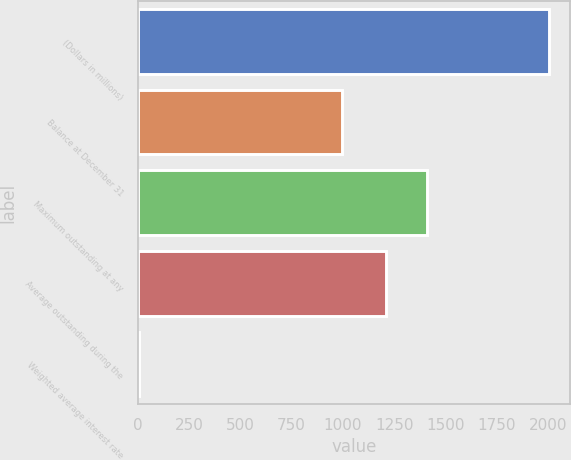<chart> <loc_0><loc_0><loc_500><loc_500><bar_chart><fcel>(Dollars in millions)<fcel>Balance at December 31<fcel>Maximum outstanding at any<fcel>Average outstanding during the<fcel>Weighted average interest rate<nl><fcel>2006<fcel>998<fcel>1411.1<fcel>1211<fcel>5<nl></chart> 